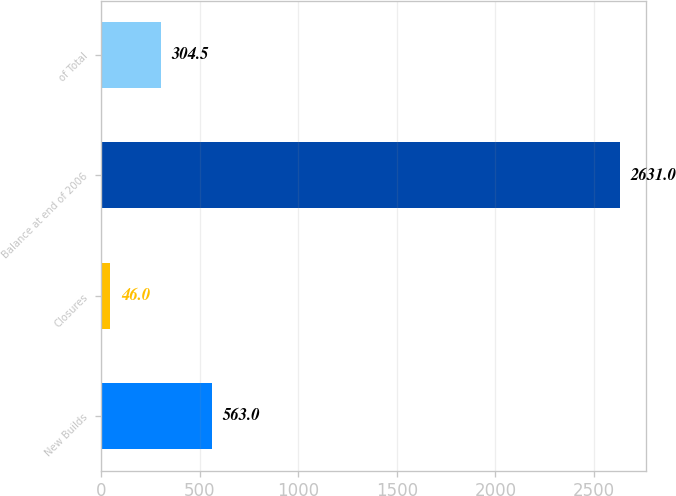<chart> <loc_0><loc_0><loc_500><loc_500><bar_chart><fcel>New Builds<fcel>Closures<fcel>Balance at end of 2006<fcel>of Total<nl><fcel>563<fcel>46<fcel>2631<fcel>304.5<nl></chart> 